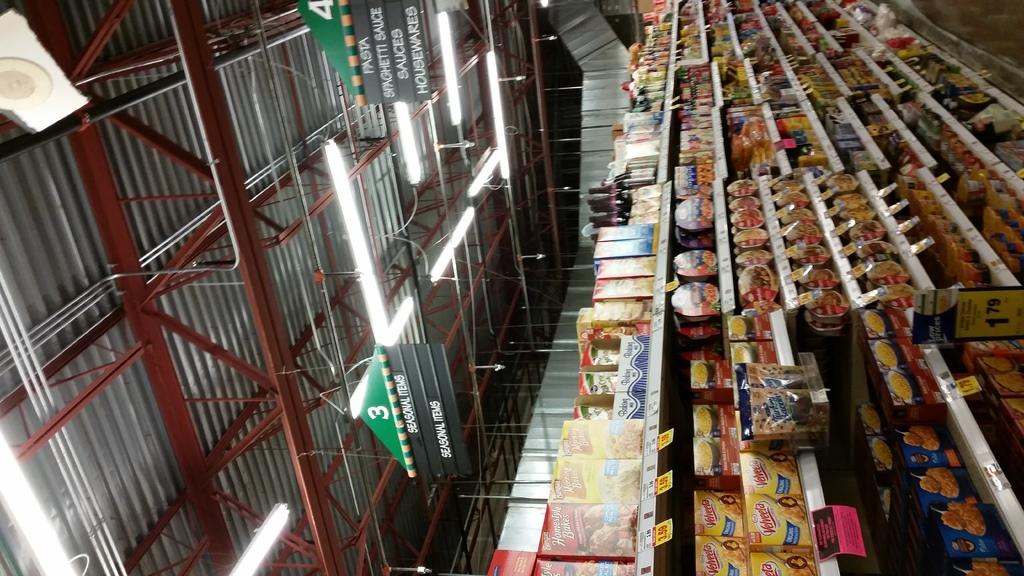In what aisle can you find pasta?
Keep it short and to the point. 4. What else is in the aisle based on sign?
Ensure brevity in your answer.  4. 